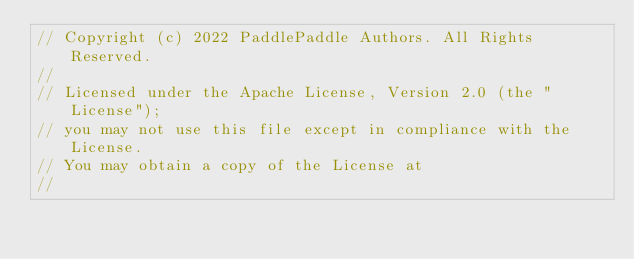<code> <loc_0><loc_0><loc_500><loc_500><_Cuda_>// Copyright (c) 2022 PaddlePaddle Authors. All Rights Reserved.
//
// Licensed under the Apache License, Version 2.0 (the "License");
// you may not use this file except in compliance with the License.
// You may obtain a copy of the License at
//</code> 